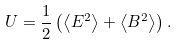<formula> <loc_0><loc_0><loc_500><loc_500>U = \frac { 1 } { 2 } \left ( \left \langle E ^ { 2 } \right \rangle + \left \langle B ^ { 2 } \right \rangle \right ) .</formula> 